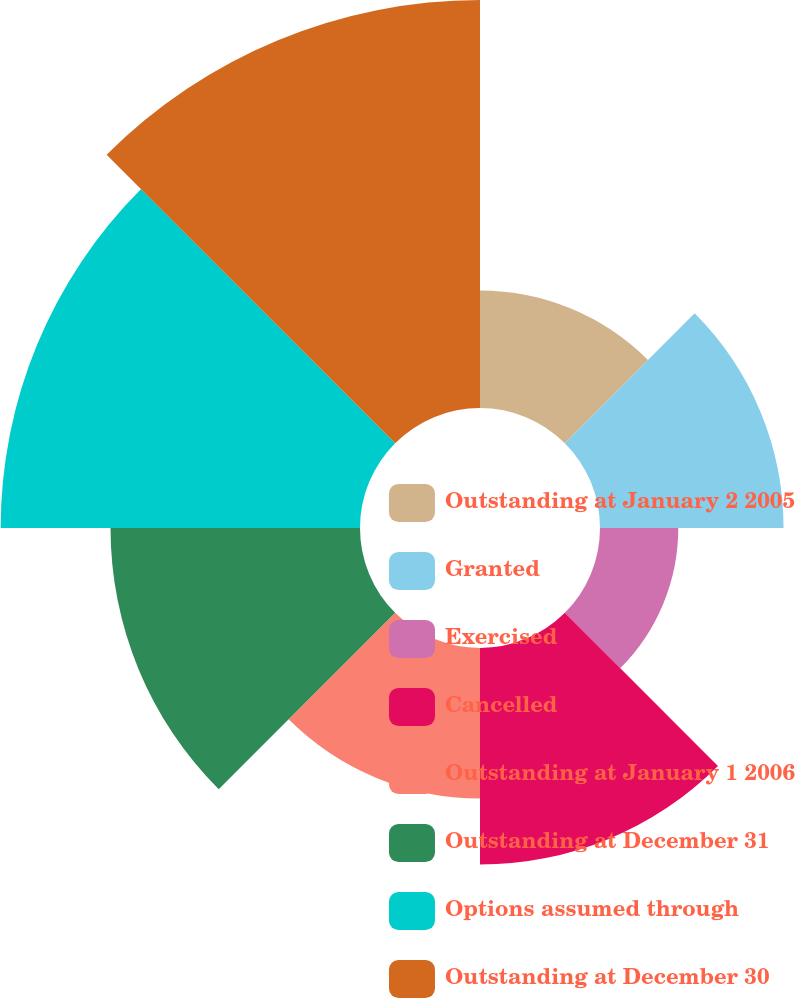<chart> <loc_0><loc_0><loc_500><loc_500><pie_chart><fcel>Outstanding at January 2 2005<fcel>Granted<fcel>Exercised<fcel>Cancelled<fcel>Outstanding at January 1 2006<fcel>Outstanding at December 31<fcel>Options assumed through<fcel>Outstanding at December 30<nl><fcel>6.67%<fcel>10.41%<fcel>4.44%<fcel>12.28%<fcel>8.54%<fcel>14.15%<fcel>20.38%<fcel>23.14%<nl></chart> 